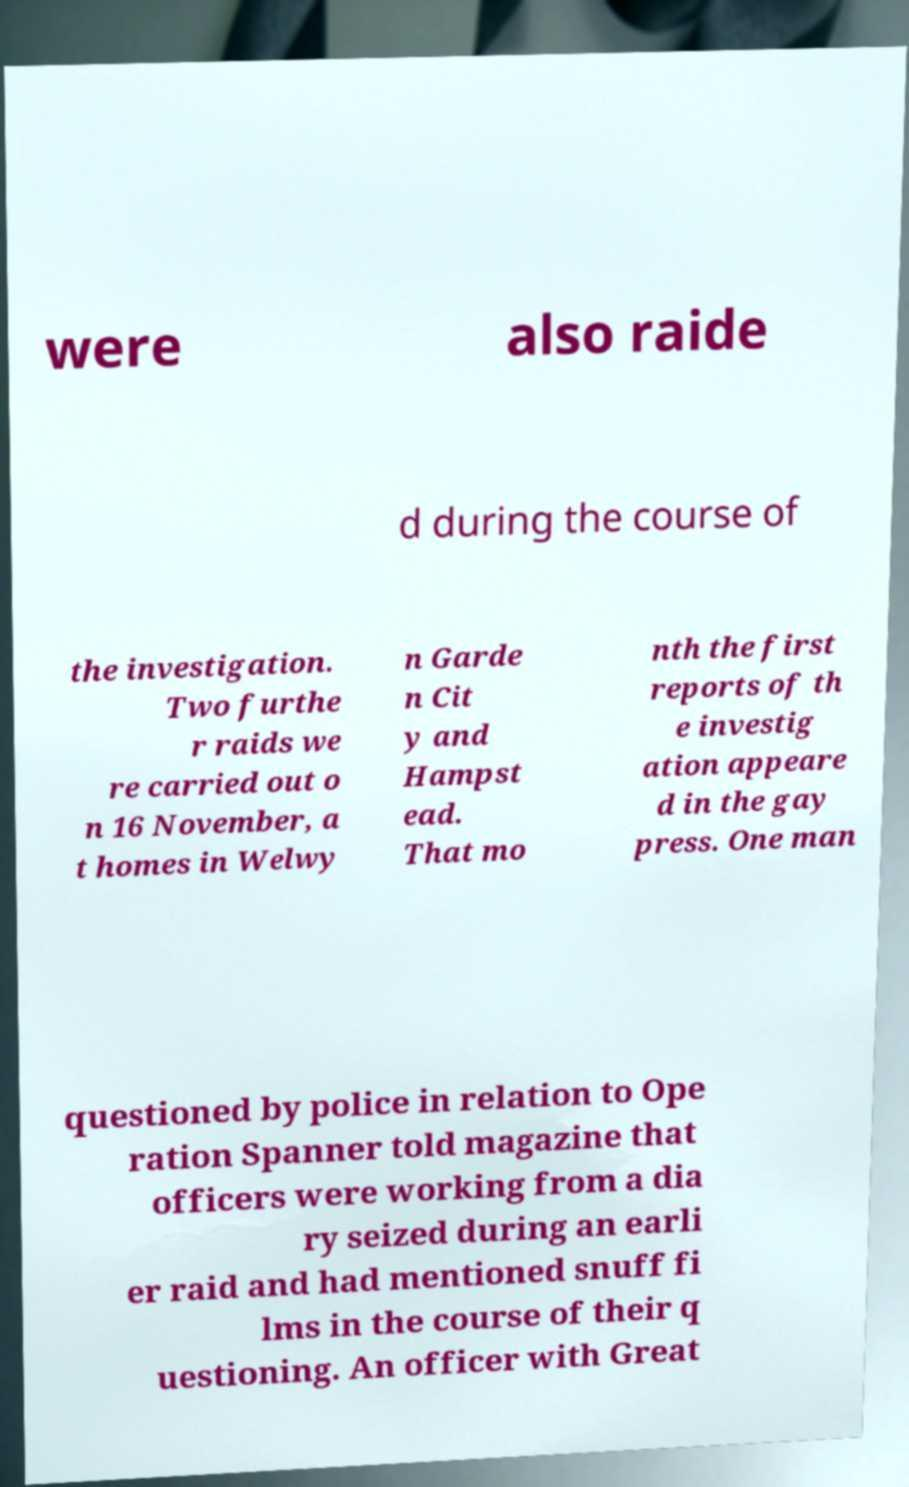Can you accurately transcribe the text from the provided image for me? were also raide d during the course of the investigation. Two furthe r raids we re carried out o n 16 November, a t homes in Welwy n Garde n Cit y and Hampst ead. That mo nth the first reports of th e investig ation appeare d in the gay press. One man questioned by police in relation to Ope ration Spanner told magazine that officers were working from a dia ry seized during an earli er raid and had mentioned snuff fi lms in the course of their q uestioning. An officer with Great 